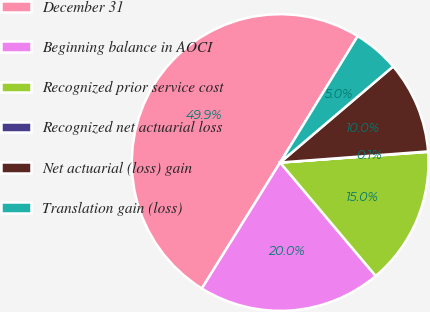Convert chart to OTSL. <chart><loc_0><loc_0><loc_500><loc_500><pie_chart><fcel>December 31<fcel>Beginning balance in AOCI<fcel>Recognized prior service cost<fcel>Recognized net actuarial loss<fcel>Net actuarial (loss) gain<fcel>Translation gain (loss)<nl><fcel>49.9%<fcel>19.99%<fcel>15.0%<fcel>0.05%<fcel>10.02%<fcel>5.03%<nl></chart> 